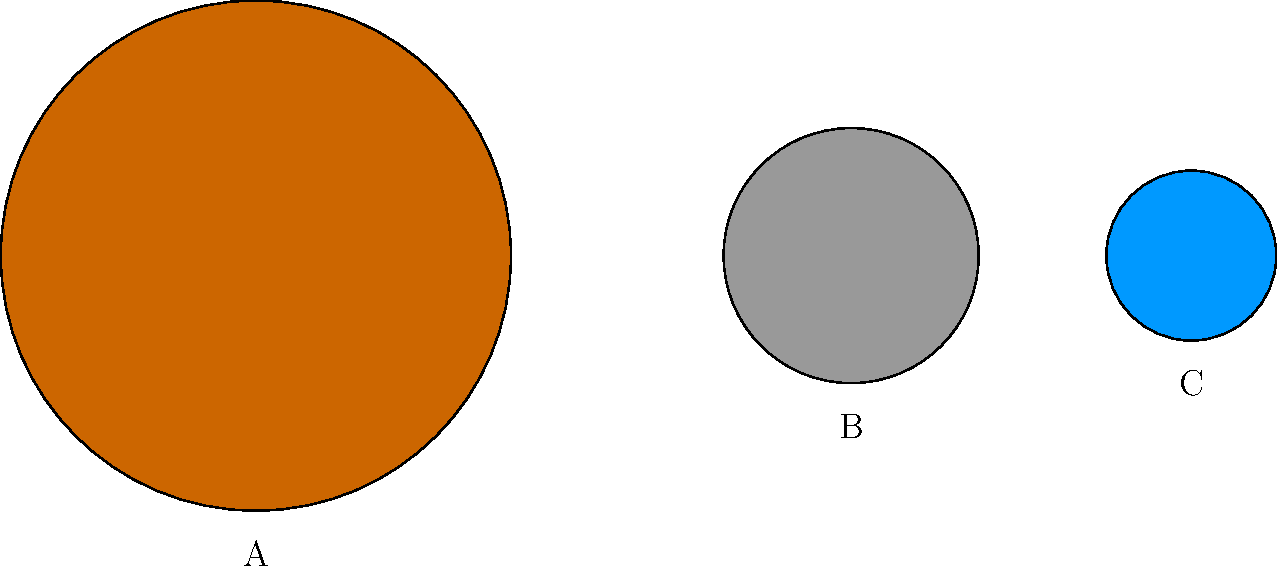In a youth sports program, you're teaching about the relative sizes of planets using scaled circles. If circle A represents Jupiter, which planet could circle B represent, and why? Let's approach this step-by-step:

1. We see three circles of different sizes: A (largest), B (medium), and C (smallest).

2. We're told that circle A represents Jupiter, which is the largest planet in our solar system.

3. To determine what B might represent, we need to consider the relative sizes of planets:

   - Jupiter (A) is the largest
   - Saturn is the second-largest planet, about 85% the size of Jupiter
   - Uranus and Neptune are similar in size, both around 35-40% the size of Jupiter
   - The terrestrial planets (Mercury, Venus, Earth, Mars) are much smaller

4. Looking at the image, we can estimate that circle B is about half the diameter of circle A.

5. This ratio is closest to the relationship between Jupiter and Saturn.

6. While the scale isn't exact (Saturn is larger than half of Jupiter), in simplified educational models, it's common to represent Saturn as about half the size of Jupiter.

Therefore, circle B most likely represents Saturn, as it's the second-largest planet and the only one that would be reasonably represented at about half the size of Jupiter in a simplified model.
Answer: Saturn 